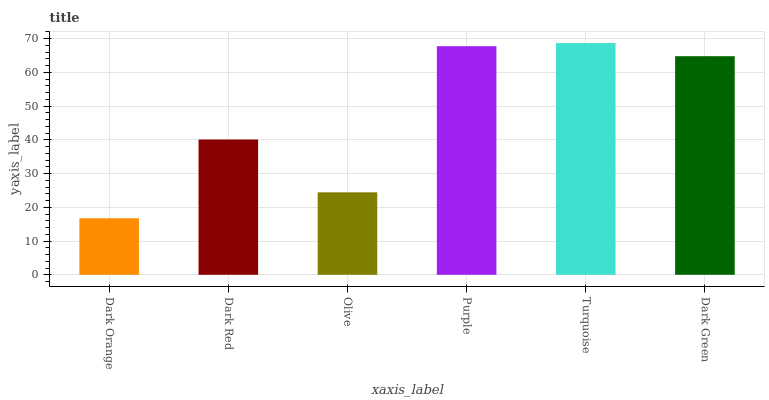Is Dark Orange the minimum?
Answer yes or no. Yes. Is Turquoise the maximum?
Answer yes or no. Yes. Is Dark Red the minimum?
Answer yes or no. No. Is Dark Red the maximum?
Answer yes or no. No. Is Dark Red greater than Dark Orange?
Answer yes or no. Yes. Is Dark Orange less than Dark Red?
Answer yes or no. Yes. Is Dark Orange greater than Dark Red?
Answer yes or no. No. Is Dark Red less than Dark Orange?
Answer yes or no. No. Is Dark Green the high median?
Answer yes or no. Yes. Is Dark Red the low median?
Answer yes or no. Yes. Is Dark Red the high median?
Answer yes or no. No. Is Dark Orange the low median?
Answer yes or no. No. 